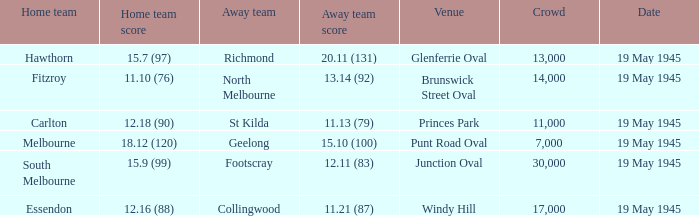What date did essendon serve as the home team? 19 May 1945. 